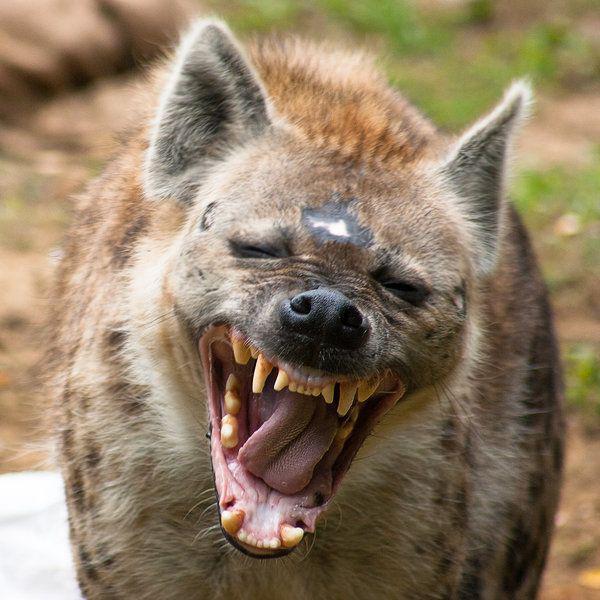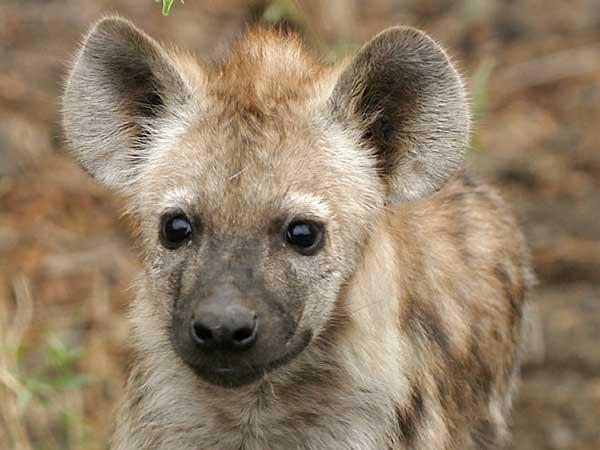The first image is the image on the left, the second image is the image on the right. Evaluate the accuracy of this statement regarding the images: "Only one animal has its mouth open wide showing its teeth and tongue.". Is it true? Answer yes or no. Yes. The first image is the image on the left, the second image is the image on the right. Considering the images on both sides, is "Only one image shows a hyena with mouth agape showing tongue and teeth." valid? Answer yes or no. Yes. 